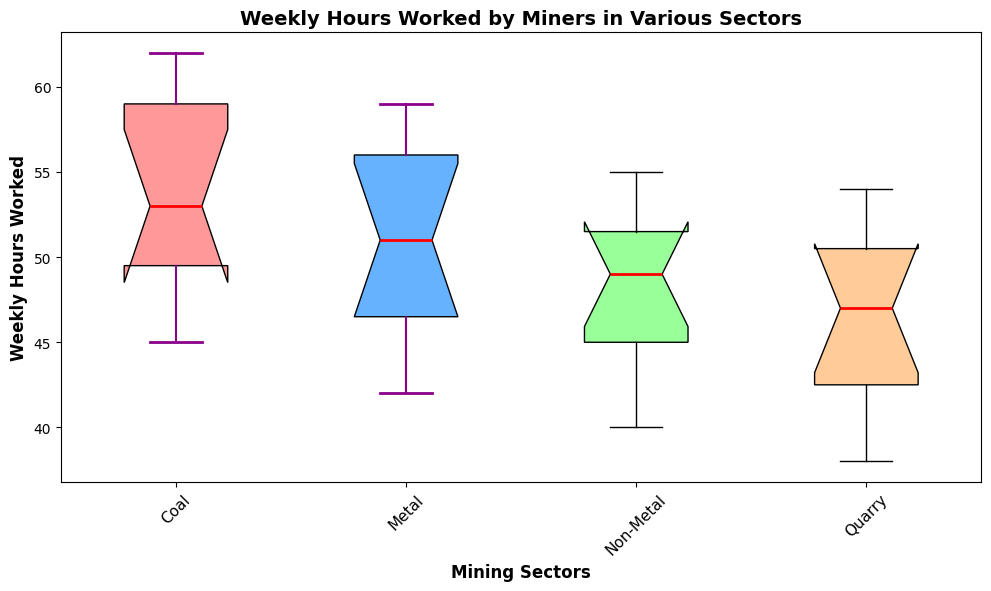What is the sector with the highest median weekly hours worked? The median is represented by the red line within each box plot. By finding the highest median line, we can determine that Coal has the highest median weekly hours worked.
Answer: Coal Which sector has the most variation in weekly hours worked? The variation in weekly hours is indicated by the size of the box and the distance between the whiskers. A larger box and longer whiskers indicate more variability. Coal has the widest box plot, suggesting the most variation in weekly hours worked.
Answer: Coal What are the minimum and maximum weekly hours worked in the Metal sector? The minimum and maximum values are indicated by the endpoints of the whiskers for each sector. For the Metal sector, the minimum is at 42 hours and the maximum is at 59 hours.
Answer: 42 and 59 Which sector has the smallest interquartile range (IQR) of weekly hours worked? The IQR is represented by the height of the box in each plot. A smaller box height indicates a smaller IQR. Quarry has the smallest IQR.
Answer: Quarry What is the difference between the median weekly hours worked in the Coal sector and the Non-Metal sector? To find the difference between the medians, locate the red median lines for Coal and Non-Metal sectors. Then, subtract the Non-Metal median from the Coal median. Coal's median is approximately 54 and Non-Metal's is approximately 50. Thus, the difference is 54 - 50 = 4.
Answer: 4 Are there any outliers in the weekly hours worked in any of the sectors? Outliers would be shown as individual points that fall outside the whiskers of the box plots. There are no points displayed outside the whiskers, indicating no outliers in any sector.
Answer: No Which sector has the least overall working hours? The least working hours are indicated by the lowest minimum value at the end of the whisker. Quarry sector shows the lowest minimum value at 38 hours.
Answer: Quarry What is the range of weekly hours worked in the Non-Metal sector? The range is calculated by subtracting the minimum value from the maximum value, as shown by the ends of the whiskers. For Non-Metal, the minimum is 40 and the maximum is 55. Thus, the range is 55 - 40 = 15.
Answer: 15 How does the median weekly hours worked in the Metal sector compare to the median weekly hours in the Quarry sector? The median is represented by the red lines within each box plot. Comparing these red lines, the Metal sector has a higher median weekly hours worked than the Quarry sector.
Answer: Higher What's the maximum value for weekly hours worked in the Coal sector, and how does it compare to the maximum value in the Metal sector? The maximum value is shown at the end of the top whisker for each sector's box plot. In the Coal sector, the maximum is 62, while in the Metal sector, the maximum is 59. Hence, the maximum value in Coal is higher than that in Metal.
Answer: 62 is higher 